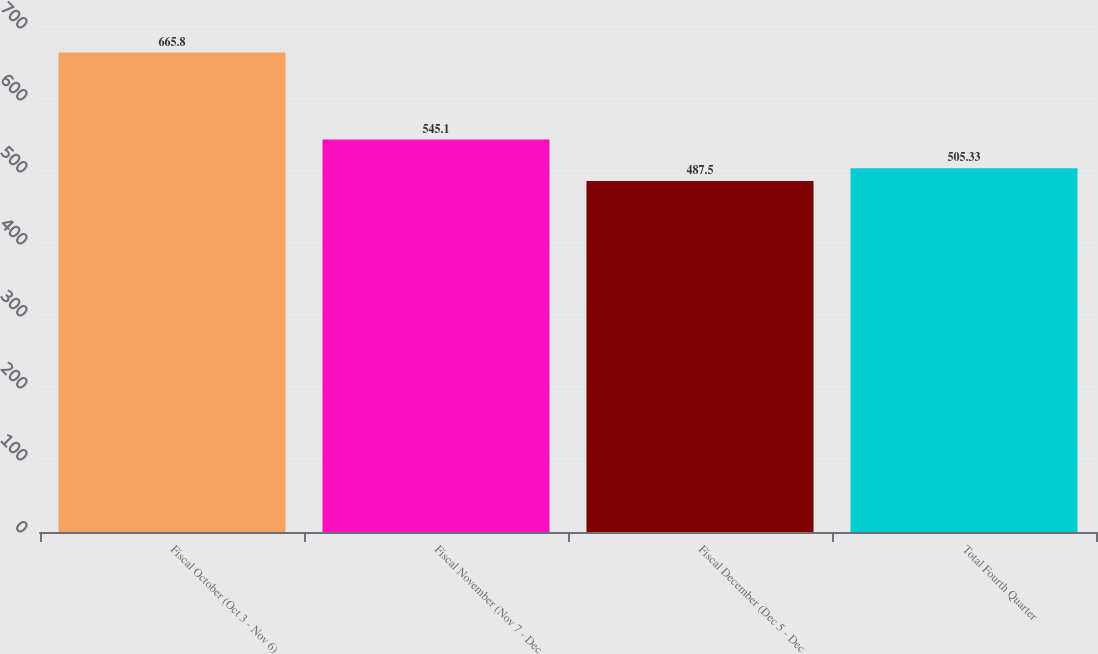<chart> <loc_0><loc_0><loc_500><loc_500><bar_chart><fcel>Fiscal October (Oct 3 - Nov 6)<fcel>Fiscal November (Nov 7 - Dec<fcel>Fiscal December (Dec 5 - Dec<fcel>Total Fourth Quarter<nl><fcel>665.8<fcel>545.1<fcel>487.5<fcel>505.33<nl></chart> 